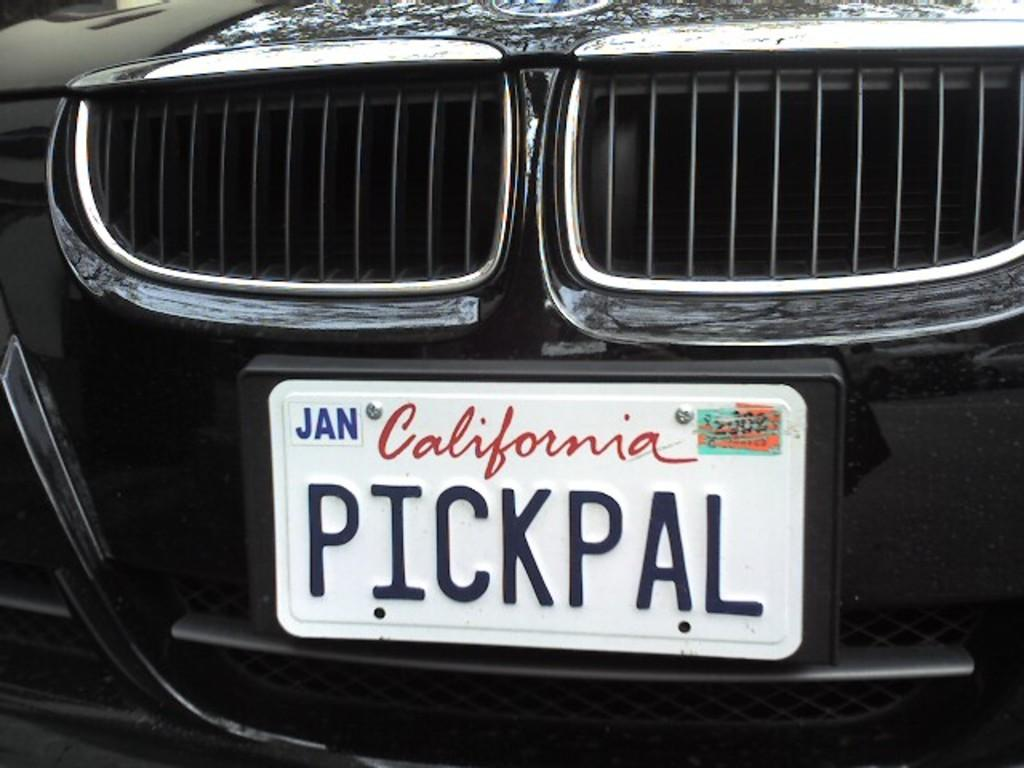<image>
Summarize the visual content of the image. A license plate from the state of California reads Pickpal. 